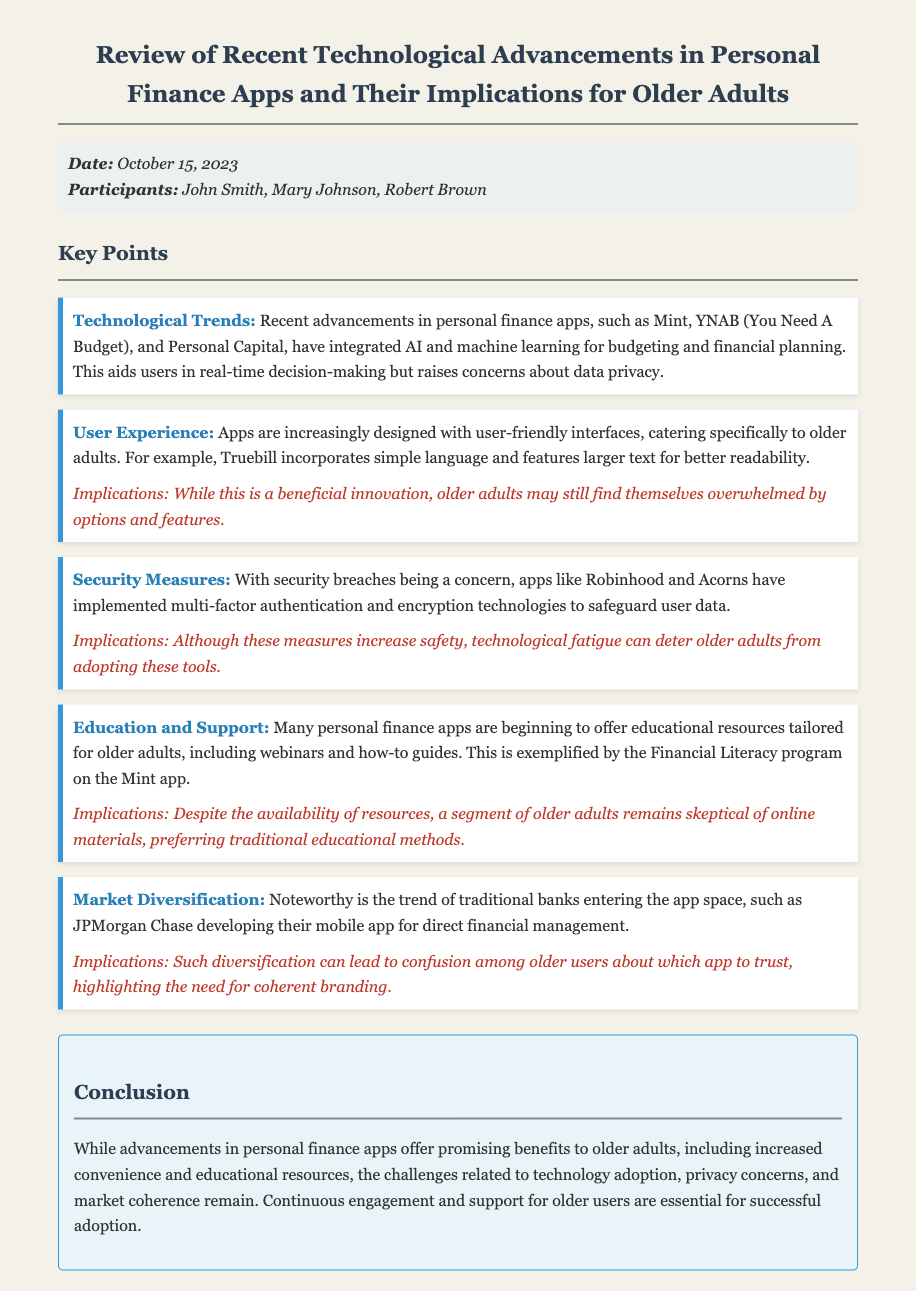What is the date of the meeting? The date of the meeting is stated in the meta section of the document.
Answer: October 15, 2023 Who are the participants in the meeting? The participants are listed in the meta section of the document.
Answer: John Smith, Mary Johnson, Robert Brown What feature did Truebill incorporate for older adults? Truebill's specific design feature aimed at older adults is mentioned in the user experience key point.
Answer: Simple language and larger text What is a concern regarding technological advancements in personal finance apps? The concern is highlighted in the technological trends key point about the usage of AI and machine learning.
Answer: Data privacy What educational resource is provided by the Mint app? The educational resource tailored for older adults is specified in the education and support key point.
Answer: Financial Literacy program How do traditional banks respond to emerging technology? The market diversification key point discusses traditional banks entering the app space.
Answer: Developing mobile apps What is the implication of security measures implemented by apps? The implications are provided in the security measures key point in relation to adoption barriers.
Answer: Technological fatigue What is a major challenge for older adults regarding personal finance apps? The conclusion summarizes the challenges faced by older adults with the advancements discussed.
Answer: Technology adoption What type of authentication is mentioned as a security measure? The security measures key point lists the type of authentication implemented by certain apps.
Answer: Multi-factor authentication 